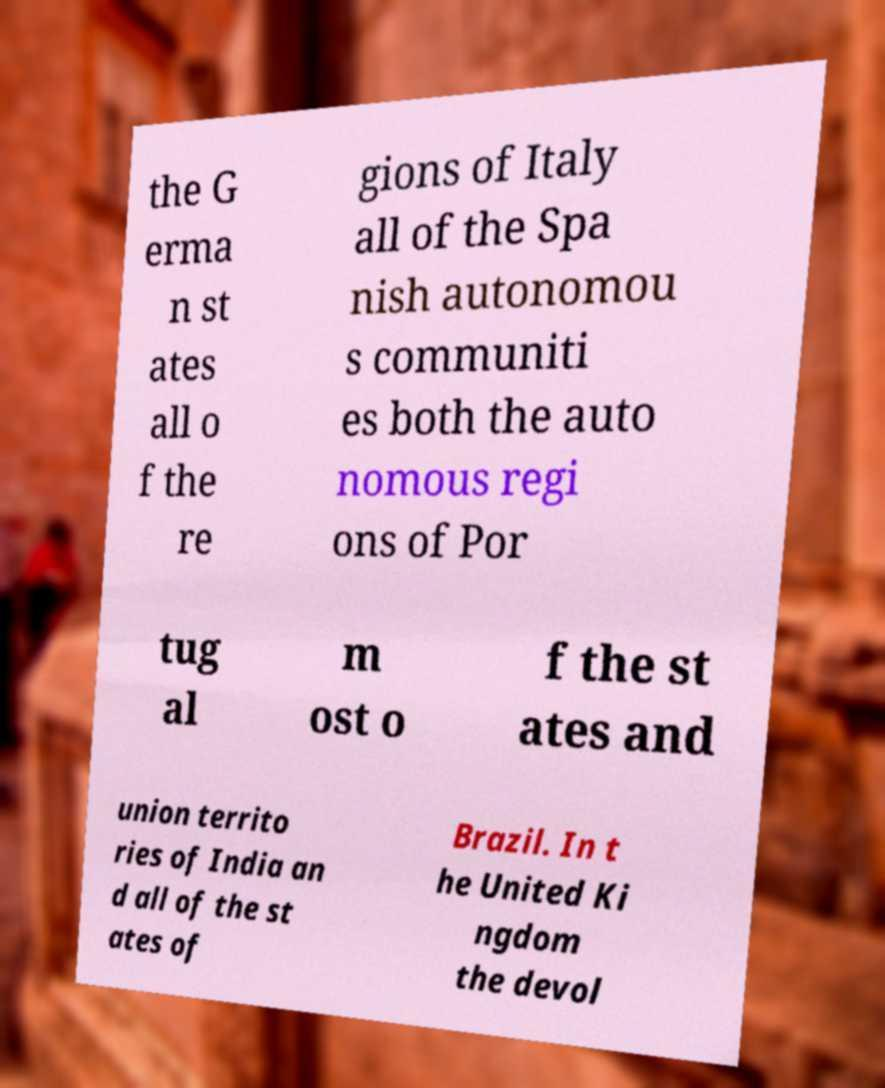Please read and relay the text visible in this image. What does it say? the G erma n st ates all o f the re gions of Italy all of the Spa nish autonomou s communiti es both the auto nomous regi ons of Por tug al m ost o f the st ates and union territo ries of India an d all of the st ates of Brazil. In t he United Ki ngdom the devol 